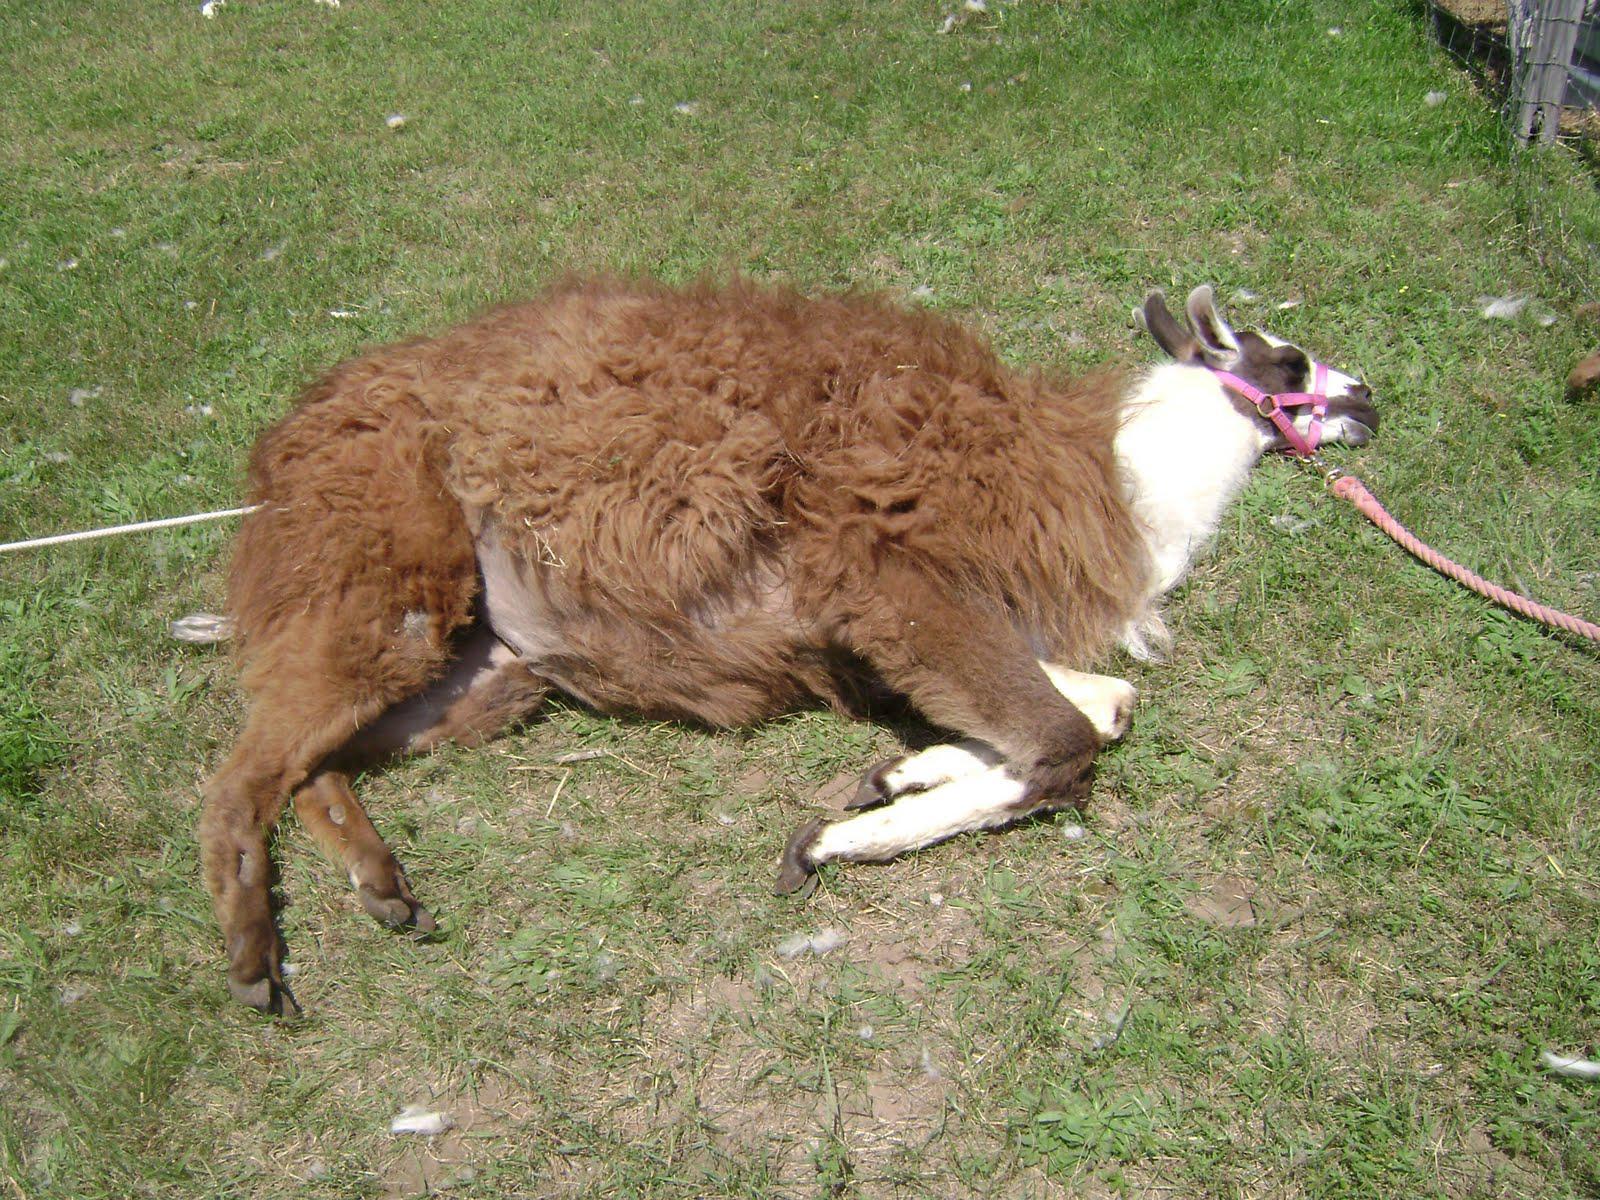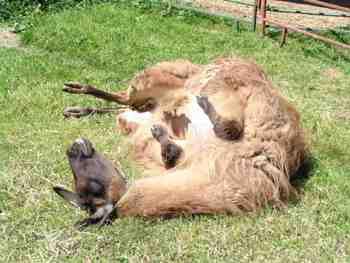The first image is the image on the left, the second image is the image on the right. Analyze the images presented: Is the assertion "Each image contains one llama lying on the ground, and the left image features a brown-and-white llma with a pink harness and a rope at its tail end lying on its side on the grass." valid? Answer yes or no. Yes. The first image is the image on the left, the second image is the image on the right. Assess this claim about the two images: "In one of the images, the llama has a leash on his neck.". Correct or not? Answer yes or no. Yes. 